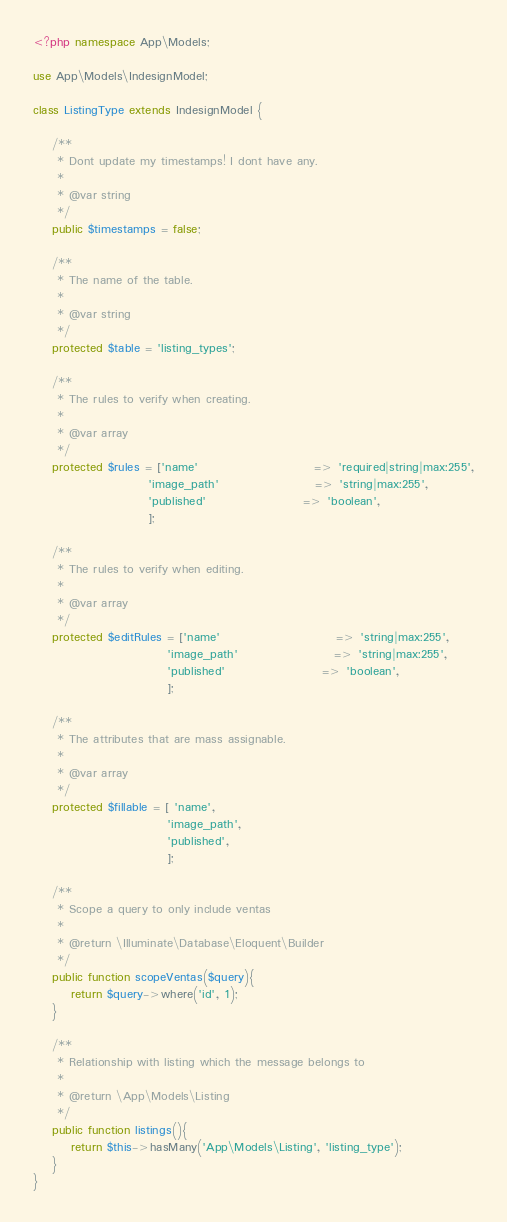<code> <loc_0><loc_0><loc_500><loc_500><_PHP_><?php namespace App\Models;

use App\Models\IndesignModel;

class ListingType extends IndesignModel {

	/**
	 * Dont update my timestamps! I dont have any.
	 *
	 * @var string
	 */
	public $timestamps = false;

	/**
	 * The name of the table.
	 *
	 * @var string
	 */
    protected $table = 'listing_types';

	/**
	 * The rules to verify when creating.
	 *
	 * @var array
	 */
	protected $rules = ['name'  						=> 'required|string|max:255',
				        'image_path'  					=> 'string|max:255',
				        'published'  					=> 'boolean',
				        ];

	/**
	 * The rules to verify when editing.
	 *
	 * @var array
	 */
	protected $editRules = ['name'  						=> 'string|max:255',
					        'image_path'  					=> 'string|max:255',
					        'published'  					=> 'boolean',
					        ];

	/**
	 * The attributes that are mass assignable.
	 *
	 * @var array
	 */
	protected $fillable = [ 'name', 
							'image_path', 
							'published',
							];

	/**
     * Scope a query to only include ventas
     *
     * @return \Illuminate\Database\Eloquent\Builder
     */
	public function scopeVentas($query){
        return $query->where('id', 1);
    }

    /**
     * Relationship with listing which the message belongs to
     *
     * @return \App\Models\Listing
     */
	public function listings(){
        return $this->hasMany('App\Models\Listing', 'listing_type');
    }
}</code> 